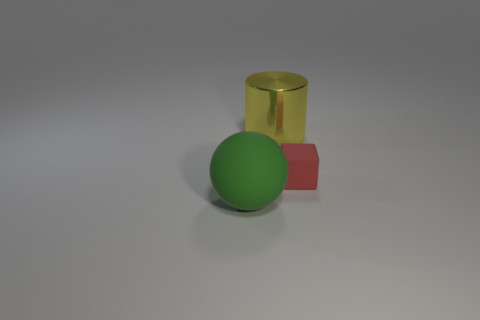Add 1 small red blocks. How many objects exist? 4 Subtract all balls. How many objects are left? 2 Add 2 red rubber things. How many red rubber things exist? 3 Subtract 0 red cylinders. How many objects are left? 3 Subtract all brown cubes. Subtract all blue spheres. How many cubes are left? 1 Subtract all large matte spheres. Subtract all small things. How many objects are left? 1 Add 3 small red blocks. How many small red blocks are left? 4 